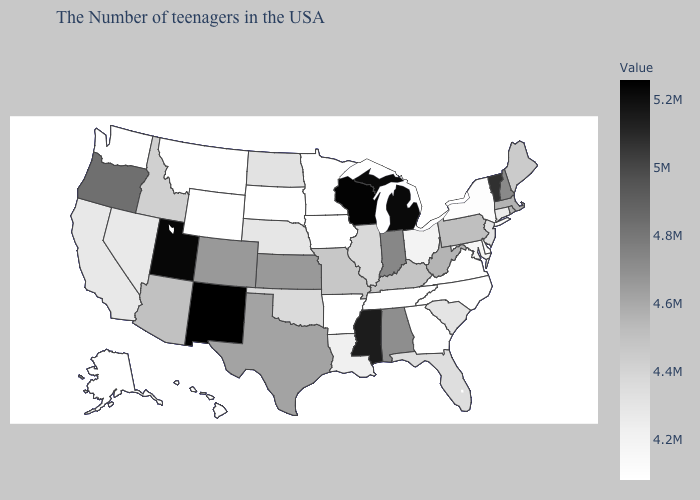Does Montana have the lowest value in the USA?
Write a very short answer. Yes. Which states have the highest value in the USA?
Write a very short answer. New Mexico. Does Vermont have a higher value than Tennessee?
Quick response, please. Yes. Does the map have missing data?
Concise answer only. No. Among the states that border Virginia , which have the lowest value?
Answer briefly. North Carolina, Tennessee. Among the states that border Mississippi , does Alabama have the highest value?
Be succinct. Yes. Among the states that border New Jersey , does Pennsylvania have the highest value?
Keep it brief. Yes. Which states have the lowest value in the South?
Short answer required. Virginia, North Carolina, Georgia, Tennessee, Arkansas. Does Wisconsin have the highest value in the MidWest?
Give a very brief answer. Yes. 